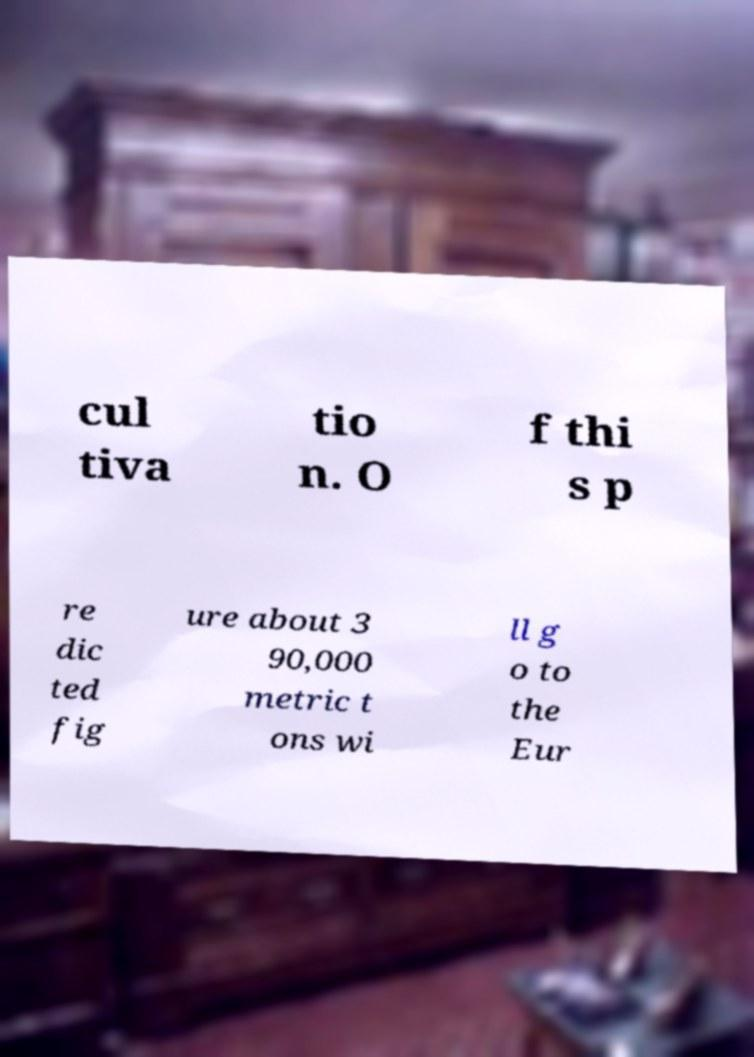Could you assist in decoding the text presented in this image and type it out clearly? cul tiva tio n. O f thi s p re dic ted fig ure about 3 90,000 metric t ons wi ll g o to the Eur 